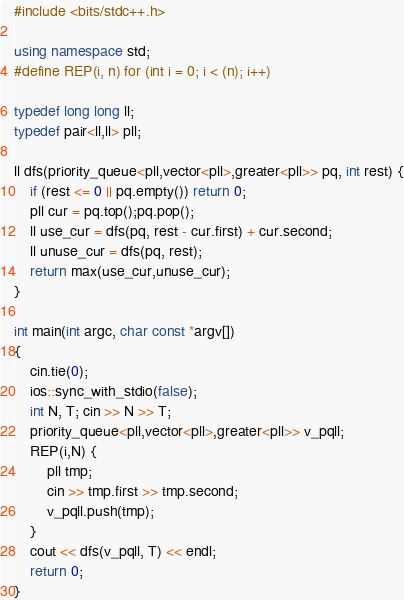<code> <loc_0><loc_0><loc_500><loc_500><_C++_>#include <bits/stdc++.h>

using namespace std; 
#define REP(i, n) for (int i = 0; i < (n); i++)

typedef long long ll;
typedef pair<ll,ll> pll;

ll dfs(priority_queue<pll,vector<pll>,greater<pll>> pq, int rest) {
    if (rest <= 0 || pq.empty()) return 0;
    pll cur = pq.top();pq.pop();
    ll use_cur = dfs(pq, rest - cur.first) + cur.second;
    ll unuse_cur = dfs(pq, rest);
    return max(use_cur,unuse_cur);
}

int main(int argc, char const *argv[])
{
    cin.tie(0);
   	ios::sync_with_stdio(false);
    int N, T; cin >> N >> T;
    priority_queue<pll,vector<pll>,greater<pll>> v_pqll;
    REP(i,N) {
        pll tmp;
        cin >> tmp.first >> tmp.second;
        v_pqll.push(tmp);
    }
    cout << dfs(v_pqll, T) << endl;
    return 0;
}
</code> 